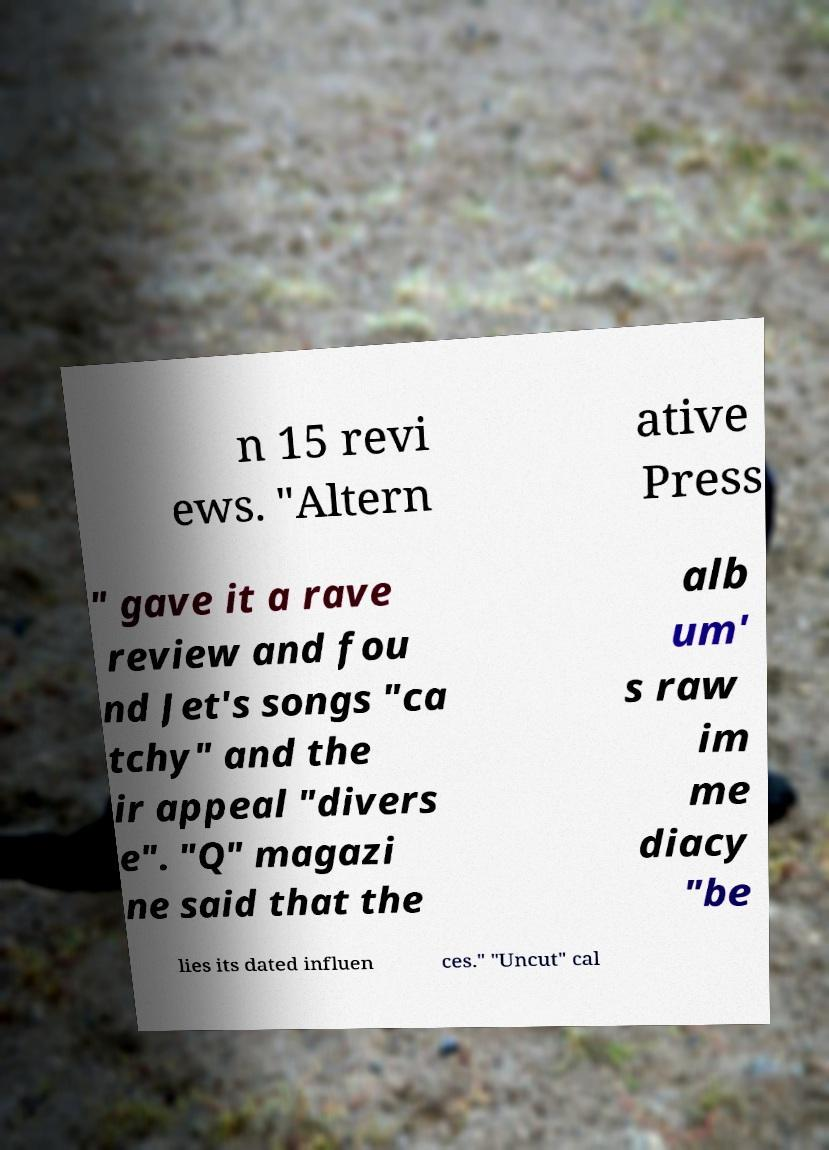Could you extract and type out the text from this image? n 15 revi ews. "Altern ative Press " gave it a rave review and fou nd Jet's songs "ca tchy" and the ir appeal "divers e". "Q" magazi ne said that the alb um' s raw im me diacy "be lies its dated influen ces." "Uncut" cal 